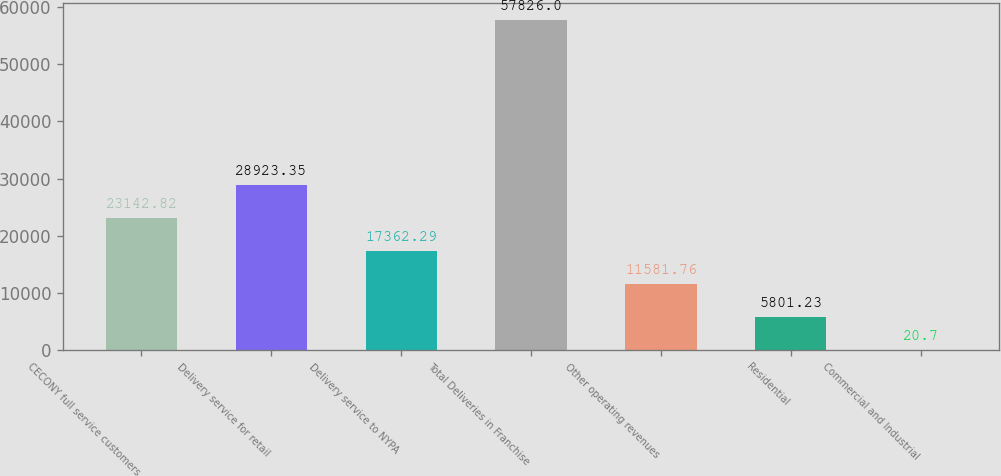Convert chart. <chart><loc_0><loc_0><loc_500><loc_500><bar_chart><fcel>CECONY full service customers<fcel>Delivery service for retail<fcel>Delivery service to NYPA<fcel>Total Deliveries in Franchise<fcel>Other operating revenues<fcel>Residential<fcel>Commercial and Industrial<nl><fcel>23142.8<fcel>28923.3<fcel>17362.3<fcel>57826<fcel>11581.8<fcel>5801.23<fcel>20.7<nl></chart> 